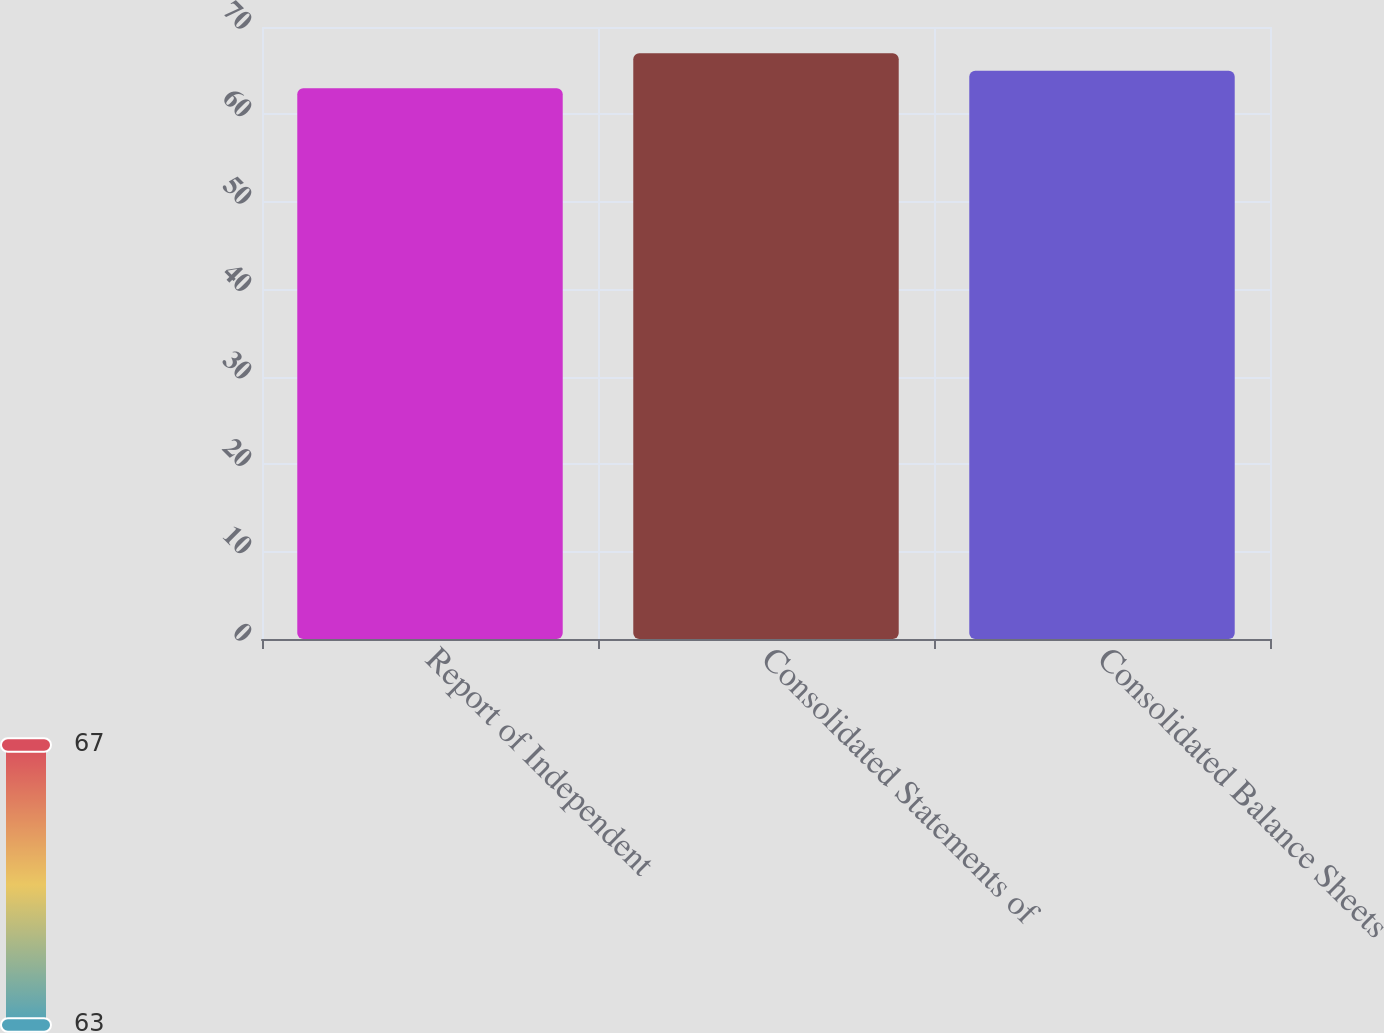Convert chart. <chart><loc_0><loc_0><loc_500><loc_500><bar_chart><fcel>Report of Independent<fcel>Consolidated Statements of<fcel>Consolidated Balance Sheets<nl><fcel>63<fcel>67<fcel>65<nl></chart> 